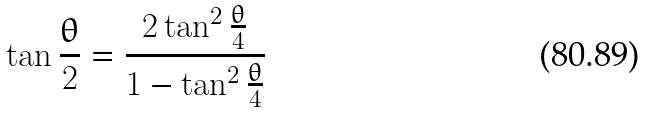Convert formula to latex. <formula><loc_0><loc_0><loc_500><loc_500>\tan { \frac { \theta } { 2 } } = \frac { 2 \tan ^ { 2 } \frac { \theta } { 4 } } { 1 - \tan ^ { 2 } \frac { \theta } { 4 } }</formula> 